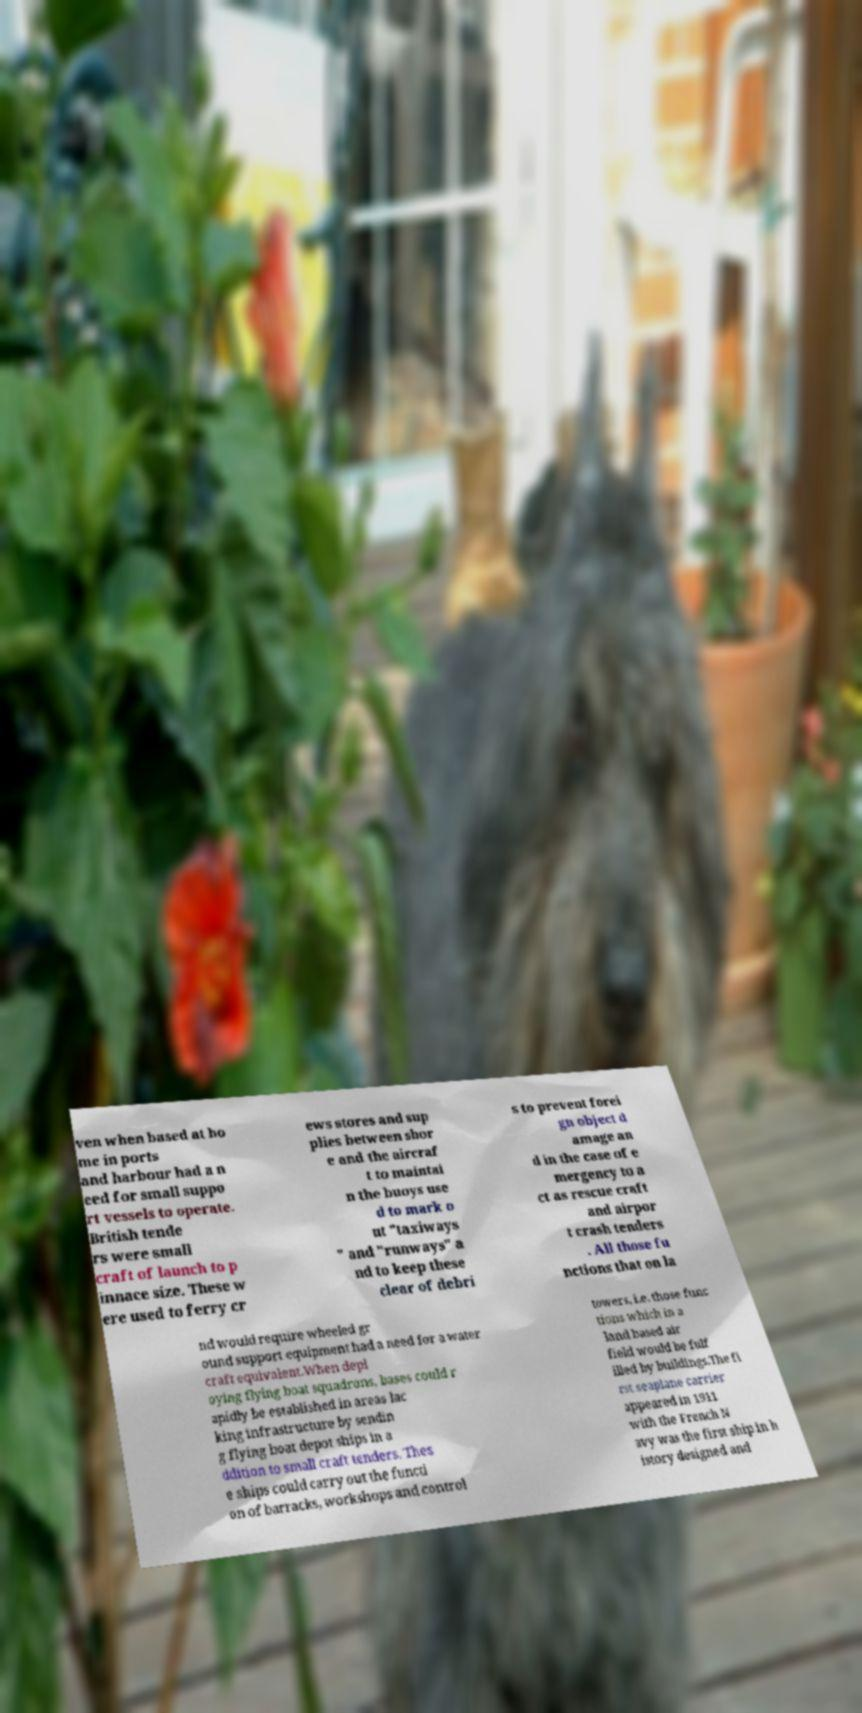There's text embedded in this image that I need extracted. Can you transcribe it verbatim? ven when based at ho me in ports and harbour had a n eed for small suppo rt vessels to operate. British tende rs were small craft of launch to p innace size. These w ere used to ferry cr ews stores and sup plies between shor e and the aircraf t to maintai n the buoys use d to mark o ut "taxiways " and "runways" a nd to keep these clear of debri s to prevent forei gn object d amage an d in the case of e mergency to a ct as rescue craft and airpor t crash tenders . All those fu nctions that on la nd would require wheeled gr ound support equipment had a need for a water craft equivalent.When depl oying flying boat squadrons, bases could r apidly be established in areas lac king infrastructure by sendin g flying boat depot ships in a ddition to small craft tenders. Thes e ships could carry out the functi on of barracks, workshops and control towers, i.e. those func tions which in a land based air field would be fulf illed by buildings.The fi rst seaplane carrier appeared in 1911 with the French N avy was the first ship in h istory designed and 